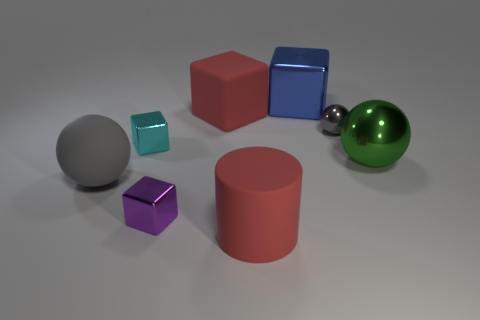What materials seem to be represented by the objects, and how can you tell? The objects in the image appear to represent a variety of materials. The big and small spheres, as well as the small cube, have reflective surfaces suggesting a glossy or metallic material. You can tell by the way they reflect light and the surrounding objects. The big cylinder and cube, however, appear matte, absorbing light, which suggests a non-reflective material possibly similar to plastic or painted metal. 